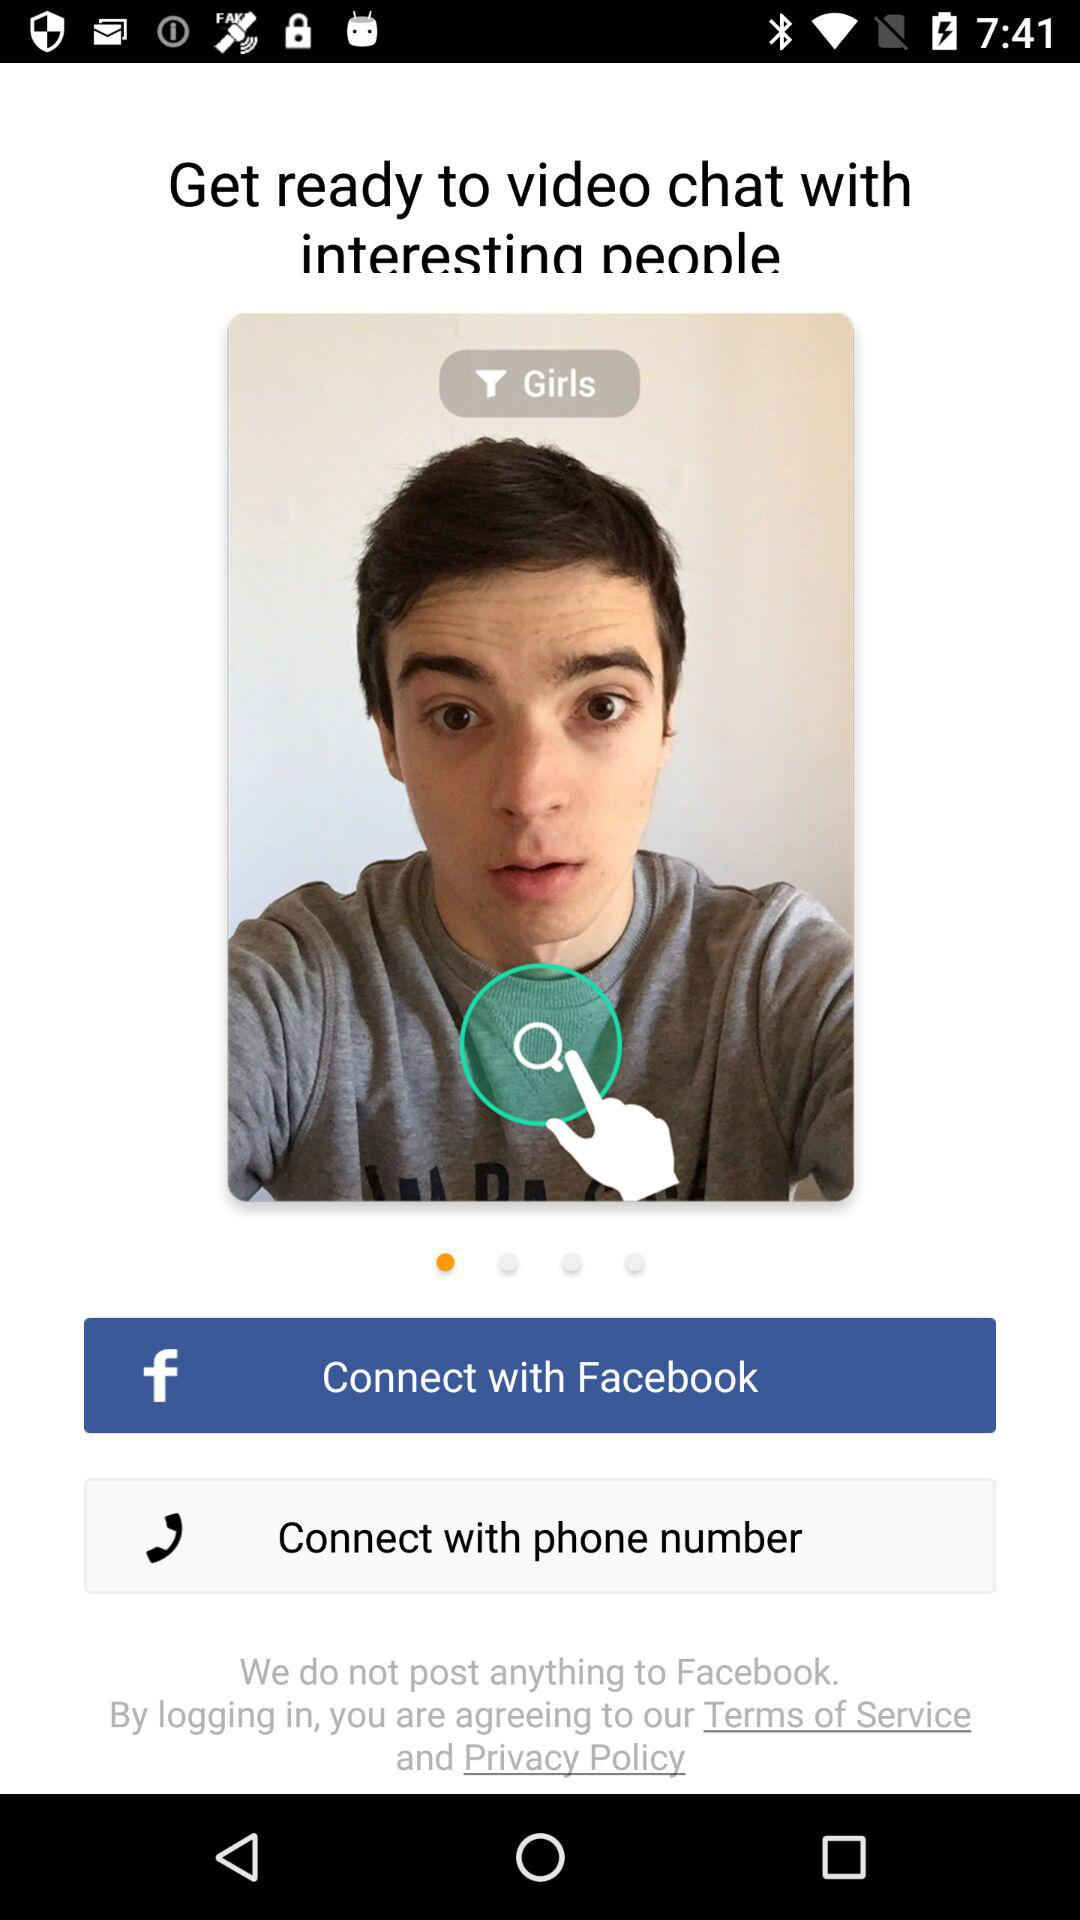What are the different options to connect? The different options to connect are "Facebook" and "phone number". 